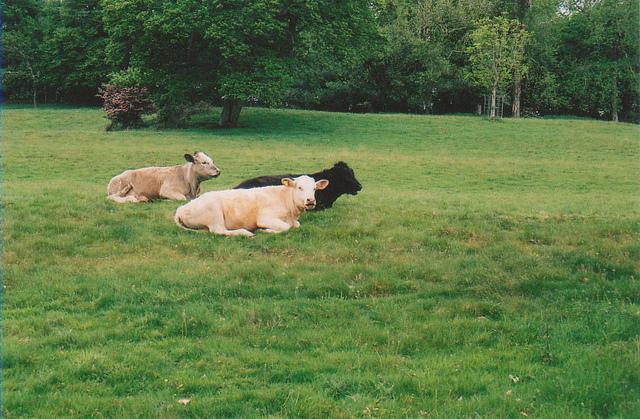How many cows are shown?
Give a very brief answer. 3. How many pairs of ears do you see?
Give a very brief answer. 3. How many cows can you see?
Give a very brief answer. 3. 